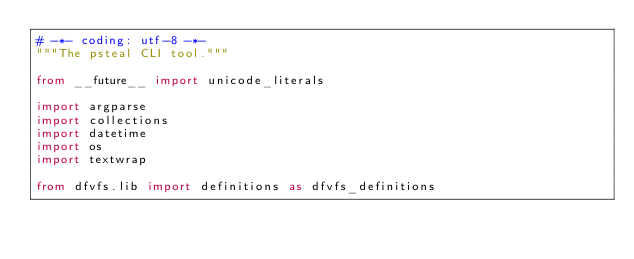<code> <loc_0><loc_0><loc_500><loc_500><_Python_># -*- coding: utf-8 -*-
"""The psteal CLI tool."""

from __future__ import unicode_literals

import argparse
import collections
import datetime
import os
import textwrap

from dfvfs.lib import definitions as dfvfs_definitions
</code> 